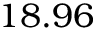<formula> <loc_0><loc_0><loc_500><loc_500>1 8 . 9 6</formula> 